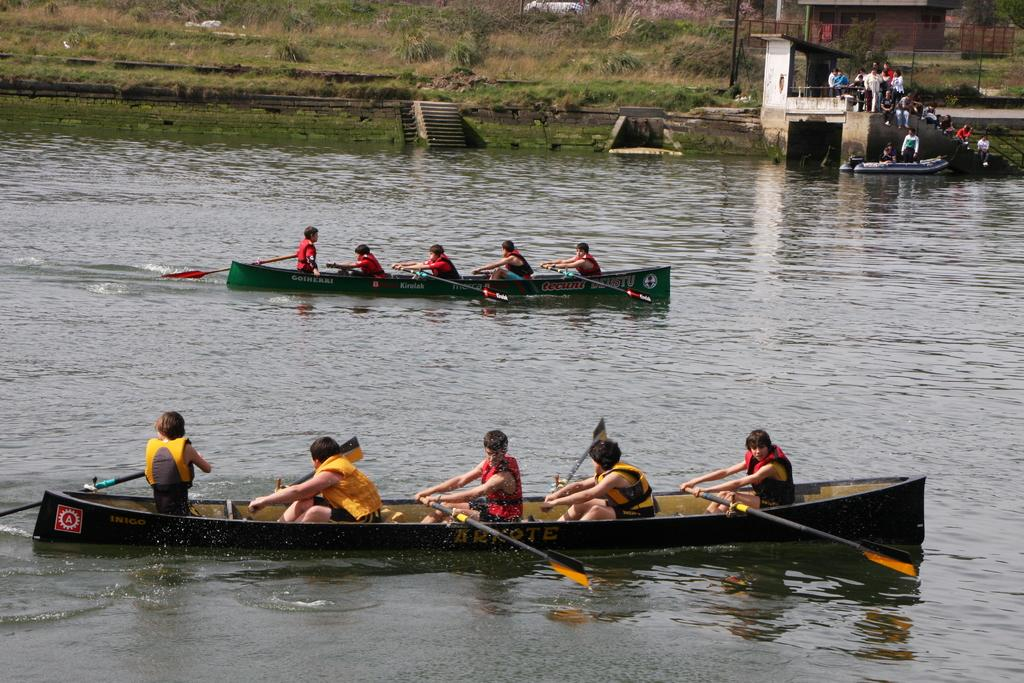What are the persons in the image doing? The persons in the image are sailing on a boat. Where is the boat located? The boat is on water. What can be seen in the background of the image? In the background of the image, there are stairs, persons, grass, and plants. What type of instrument is being played by the icicle in the image? There is no icicle present in the image, and therefore no instrument can be played by it. 